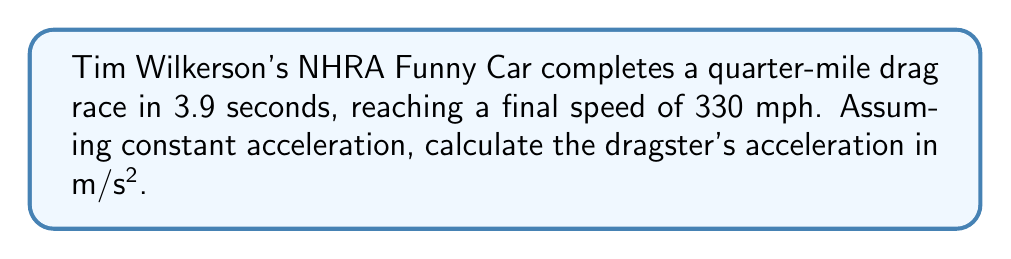Could you help me with this problem? To solve this problem, we'll use the equations of motion for constant acceleration. Let's break it down step-by-step:

1) First, let's convert our units:
   - Quarter-mile to meters: 1/4 mile = 402.336 meters
   - 330 mph to m/s: 330 * 1609.344 / 3600 = 147.51 m/s

2) We'll use the equation:
   $$ v = u + at $$
   Where:
   $v$ = final velocity (147.51 m/s)
   $u$ = initial velocity (0 m/s, as the car starts from rest)
   $a$ = acceleration (what we're solving for)
   $t$ = time (3.9 seconds)

3) Substituting our values:
   $$ 147.51 = 0 + a(3.9) $$

4) Solving for $a$:
   $$ a = \frac{147.51}{3.9} = 37.82 \text{ m/s²} $$

5) We can verify this using the displacement equation:
   $$ s = ut + \frac{1}{2}at^2 $$
   Where $s$ is the displacement (402.336 m)

6) Substituting our values:
   $$ 402.336 = 0 + \frac{1}{2}(37.82)(3.9)^2 $$
   $$ 402.336 = 287.92 $$

   The slight discrepancy is due to rounding and the assumption of constant acceleration, which isn't entirely accurate in real drag racing.
Answer: $37.82 \text{ m/s²}$ 